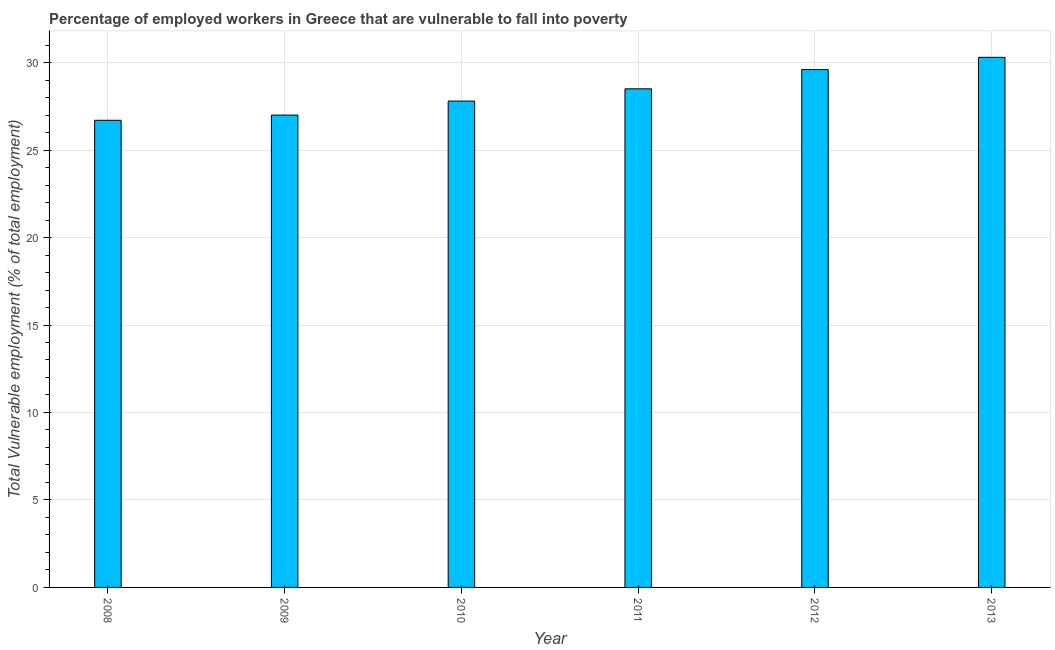Does the graph contain any zero values?
Your response must be concise. No. Does the graph contain grids?
Ensure brevity in your answer.  Yes. What is the title of the graph?
Your response must be concise. Percentage of employed workers in Greece that are vulnerable to fall into poverty. What is the label or title of the Y-axis?
Offer a very short reply. Total Vulnerable employment (% of total employment). Across all years, what is the maximum total vulnerable employment?
Offer a terse response. 30.3. Across all years, what is the minimum total vulnerable employment?
Make the answer very short. 26.7. In which year was the total vulnerable employment maximum?
Keep it short and to the point. 2013. What is the sum of the total vulnerable employment?
Your answer should be compact. 169.9. What is the average total vulnerable employment per year?
Make the answer very short. 28.32. What is the median total vulnerable employment?
Provide a succinct answer. 28.15. In how many years, is the total vulnerable employment greater than 21 %?
Your response must be concise. 6. Do a majority of the years between 2008 and 2013 (inclusive) have total vulnerable employment greater than 7 %?
Your answer should be very brief. Yes. Is the difference between the total vulnerable employment in 2009 and 2011 greater than the difference between any two years?
Offer a very short reply. No. Is the sum of the total vulnerable employment in 2008 and 2010 greater than the maximum total vulnerable employment across all years?
Keep it short and to the point. Yes. What is the difference between the highest and the lowest total vulnerable employment?
Give a very brief answer. 3.6. In how many years, is the total vulnerable employment greater than the average total vulnerable employment taken over all years?
Your answer should be very brief. 3. Are all the bars in the graph horizontal?
Ensure brevity in your answer.  No. What is the difference between two consecutive major ticks on the Y-axis?
Ensure brevity in your answer.  5. Are the values on the major ticks of Y-axis written in scientific E-notation?
Offer a very short reply. No. What is the Total Vulnerable employment (% of total employment) in 2008?
Provide a short and direct response. 26.7. What is the Total Vulnerable employment (% of total employment) of 2010?
Make the answer very short. 27.8. What is the Total Vulnerable employment (% of total employment) in 2012?
Your response must be concise. 29.6. What is the Total Vulnerable employment (% of total employment) in 2013?
Your answer should be very brief. 30.3. What is the difference between the Total Vulnerable employment (% of total employment) in 2008 and 2011?
Keep it short and to the point. -1.8. What is the difference between the Total Vulnerable employment (% of total employment) in 2009 and 2013?
Your response must be concise. -3.3. What is the difference between the Total Vulnerable employment (% of total employment) in 2010 and 2011?
Your response must be concise. -0.7. What is the difference between the Total Vulnerable employment (% of total employment) in 2010 and 2012?
Make the answer very short. -1.8. What is the difference between the Total Vulnerable employment (% of total employment) in 2011 and 2012?
Give a very brief answer. -1.1. What is the ratio of the Total Vulnerable employment (% of total employment) in 2008 to that in 2011?
Offer a terse response. 0.94. What is the ratio of the Total Vulnerable employment (% of total employment) in 2008 to that in 2012?
Your answer should be very brief. 0.9. What is the ratio of the Total Vulnerable employment (% of total employment) in 2008 to that in 2013?
Provide a short and direct response. 0.88. What is the ratio of the Total Vulnerable employment (% of total employment) in 2009 to that in 2010?
Provide a short and direct response. 0.97. What is the ratio of the Total Vulnerable employment (% of total employment) in 2009 to that in 2011?
Give a very brief answer. 0.95. What is the ratio of the Total Vulnerable employment (% of total employment) in 2009 to that in 2012?
Provide a short and direct response. 0.91. What is the ratio of the Total Vulnerable employment (% of total employment) in 2009 to that in 2013?
Provide a succinct answer. 0.89. What is the ratio of the Total Vulnerable employment (% of total employment) in 2010 to that in 2012?
Make the answer very short. 0.94. What is the ratio of the Total Vulnerable employment (% of total employment) in 2010 to that in 2013?
Your answer should be compact. 0.92. What is the ratio of the Total Vulnerable employment (% of total employment) in 2011 to that in 2013?
Your answer should be very brief. 0.94. What is the ratio of the Total Vulnerable employment (% of total employment) in 2012 to that in 2013?
Your answer should be very brief. 0.98. 